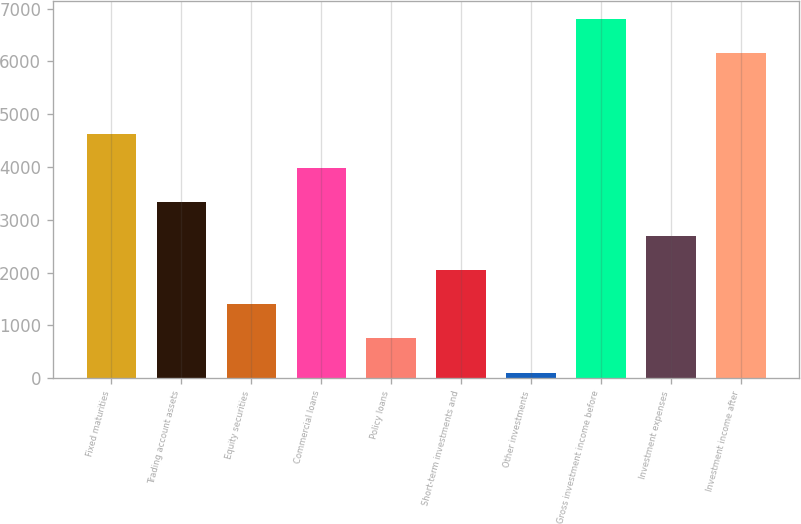<chart> <loc_0><loc_0><loc_500><loc_500><bar_chart><fcel>Fixed maturities<fcel>Trading account assets<fcel>Equity securities<fcel>Commercial loans<fcel>Policy loans<fcel>Short-term investments and<fcel>Other investments<fcel>Gross investment income before<fcel>Investment expenses<fcel>Investment income after<nl><fcel>4629.4<fcel>3337<fcel>1398.4<fcel>3983.2<fcel>752.2<fcel>2044.6<fcel>106<fcel>6795.2<fcel>2690.8<fcel>6149<nl></chart> 